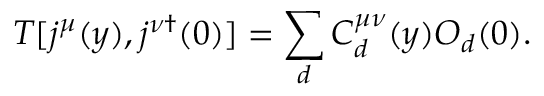<formula> <loc_0><loc_0><loc_500><loc_500>T [ j ^ { \mu } ( y ) , j ^ { \nu \dagger } ( 0 ) ] = \sum _ { d } C _ { d } ^ { \mu \nu } ( y ) O _ { d } ( 0 ) .</formula> 